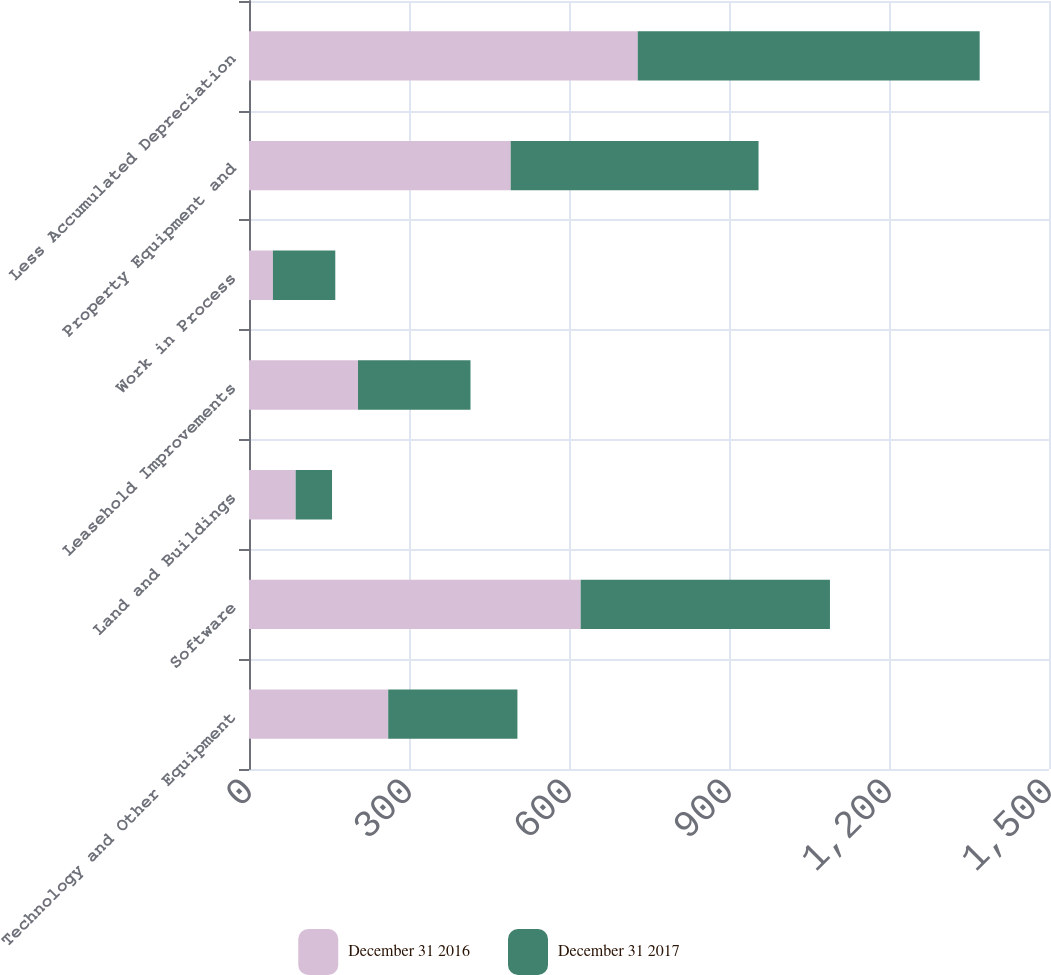<chart> <loc_0><loc_0><loc_500><loc_500><stacked_bar_chart><ecel><fcel>Technology and Other Equipment<fcel>Software<fcel>Land and Buildings<fcel>Leasehold Improvements<fcel>Work in Process<fcel>Property Equipment and<fcel>Less Accumulated Depreciation<nl><fcel>December 31 2016<fcel>261<fcel>621.9<fcel>87.5<fcel>204.4<fcel>44.8<fcel>490.7<fcel>728.9<nl><fcel>December 31 2017<fcel>242.3<fcel>467.4<fcel>68.2<fcel>210.9<fcel>117<fcel>464.7<fcel>641.1<nl></chart> 